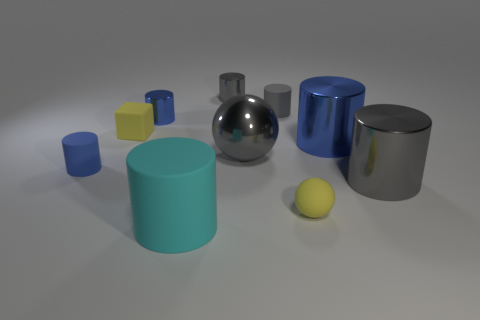There is a large object that is the same color as the shiny ball; what material is it?
Keep it short and to the point. Metal. There is a tiny thing that is in front of the yellow cube and to the right of the yellow block; what is its material?
Your response must be concise. Rubber. Is there a blue metallic object in front of the yellow rubber cube to the left of the tiny gray matte cylinder?
Offer a very short reply. Yes. How big is the blue object that is both in front of the small block and to the right of the small matte cube?
Ensure brevity in your answer.  Large. How many blue objects are either metal spheres or small metallic balls?
Offer a terse response. 0. The gray matte thing that is the same size as the yellow block is what shape?
Your answer should be compact. Cylinder. How many other things are the same color as the big ball?
Your response must be concise. 3. There is a yellow matte thing in front of the tiny yellow rubber object that is behind the tiny blue rubber object; what size is it?
Your answer should be very brief. Small. Is the material of the tiny yellow thing that is right of the large cyan rubber cylinder the same as the tiny cube?
Offer a terse response. Yes. What is the shape of the large gray thing that is on the left side of the rubber ball?
Ensure brevity in your answer.  Sphere. 